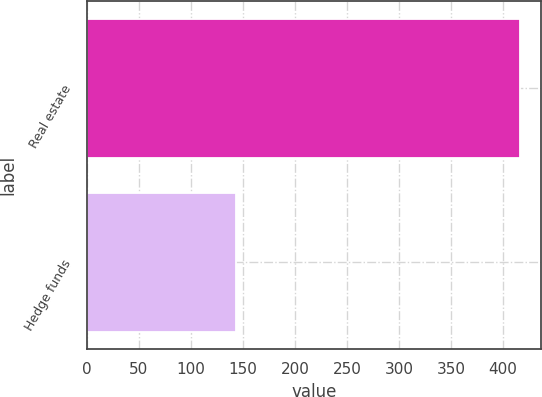Convert chart to OTSL. <chart><loc_0><loc_0><loc_500><loc_500><bar_chart><fcel>Real estate<fcel>Hedge funds<nl><fcel>416<fcel>143<nl></chart> 